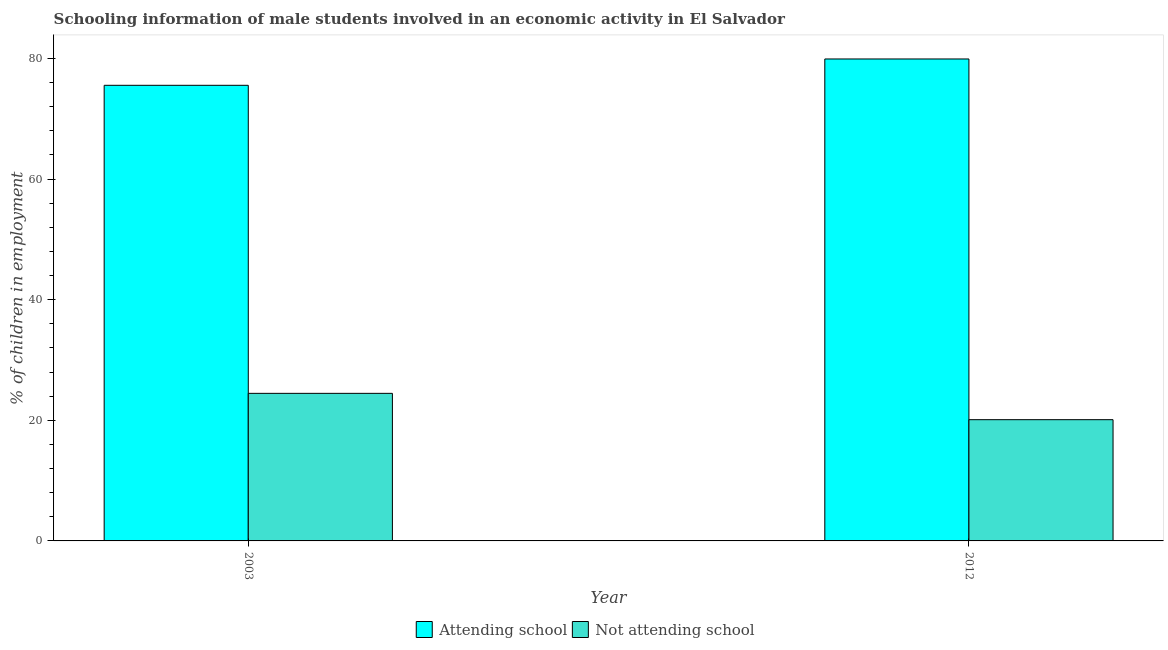How many different coloured bars are there?
Provide a succinct answer. 2. How many groups of bars are there?
Offer a terse response. 2. Are the number of bars per tick equal to the number of legend labels?
Give a very brief answer. Yes. How many bars are there on the 2nd tick from the right?
Your answer should be very brief. 2. What is the label of the 2nd group of bars from the left?
Your response must be concise. 2012. What is the percentage of employed males who are not attending school in 2003?
Make the answer very short. 24.47. Across all years, what is the maximum percentage of employed males who are not attending school?
Keep it short and to the point. 24.47. Across all years, what is the minimum percentage of employed males who are attending school?
Keep it short and to the point. 75.53. In which year was the percentage of employed males who are not attending school maximum?
Provide a succinct answer. 2003. In which year was the percentage of employed males who are attending school minimum?
Provide a short and direct response. 2003. What is the total percentage of employed males who are not attending school in the graph?
Give a very brief answer. 44.57. What is the difference between the percentage of employed males who are attending school in 2003 and that in 2012?
Your response must be concise. -4.37. What is the difference between the percentage of employed males who are attending school in 2012 and the percentage of employed males who are not attending school in 2003?
Give a very brief answer. 4.37. What is the average percentage of employed males who are not attending school per year?
Your answer should be compact. 22.28. In the year 2012, what is the difference between the percentage of employed males who are attending school and percentage of employed males who are not attending school?
Keep it short and to the point. 0. What is the ratio of the percentage of employed males who are attending school in 2003 to that in 2012?
Your answer should be very brief. 0.95. What does the 1st bar from the left in 2012 represents?
Give a very brief answer. Attending school. What does the 1st bar from the right in 2003 represents?
Ensure brevity in your answer.  Not attending school. How many bars are there?
Your answer should be very brief. 4. How many years are there in the graph?
Give a very brief answer. 2. What is the title of the graph?
Offer a terse response. Schooling information of male students involved in an economic activity in El Salvador. What is the label or title of the X-axis?
Keep it short and to the point. Year. What is the label or title of the Y-axis?
Make the answer very short. % of children in employment. What is the % of children in employment in Attending school in 2003?
Offer a terse response. 75.53. What is the % of children in employment in Not attending school in 2003?
Offer a very short reply. 24.47. What is the % of children in employment in Attending school in 2012?
Your answer should be very brief. 79.9. What is the % of children in employment in Not attending school in 2012?
Offer a terse response. 20.1. Across all years, what is the maximum % of children in employment in Attending school?
Your answer should be very brief. 79.9. Across all years, what is the maximum % of children in employment in Not attending school?
Your answer should be very brief. 24.47. Across all years, what is the minimum % of children in employment in Attending school?
Your answer should be very brief. 75.53. Across all years, what is the minimum % of children in employment in Not attending school?
Offer a terse response. 20.1. What is the total % of children in employment in Attending school in the graph?
Make the answer very short. 155.43. What is the total % of children in employment in Not attending school in the graph?
Provide a short and direct response. 44.57. What is the difference between the % of children in employment of Attending school in 2003 and that in 2012?
Keep it short and to the point. -4.37. What is the difference between the % of children in employment of Not attending school in 2003 and that in 2012?
Offer a very short reply. 4.37. What is the difference between the % of children in employment of Attending school in 2003 and the % of children in employment of Not attending school in 2012?
Give a very brief answer. 55.43. What is the average % of children in employment of Attending school per year?
Your answer should be very brief. 77.72. What is the average % of children in employment in Not attending school per year?
Your response must be concise. 22.28. In the year 2003, what is the difference between the % of children in employment in Attending school and % of children in employment in Not attending school?
Make the answer very short. 51.07. In the year 2012, what is the difference between the % of children in employment in Attending school and % of children in employment in Not attending school?
Offer a terse response. 59.8. What is the ratio of the % of children in employment of Attending school in 2003 to that in 2012?
Make the answer very short. 0.95. What is the ratio of the % of children in employment of Not attending school in 2003 to that in 2012?
Keep it short and to the point. 1.22. What is the difference between the highest and the second highest % of children in employment of Attending school?
Provide a short and direct response. 4.37. What is the difference between the highest and the second highest % of children in employment in Not attending school?
Provide a succinct answer. 4.37. What is the difference between the highest and the lowest % of children in employment in Attending school?
Your response must be concise. 4.37. What is the difference between the highest and the lowest % of children in employment of Not attending school?
Ensure brevity in your answer.  4.37. 